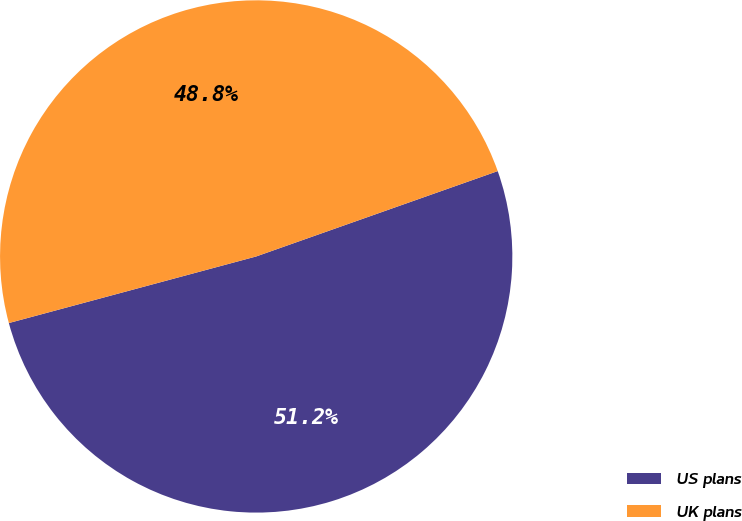Convert chart to OTSL. <chart><loc_0><loc_0><loc_500><loc_500><pie_chart><fcel>US plans<fcel>UK plans<nl><fcel>51.22%<fcel>48.78%<nl></chart> 